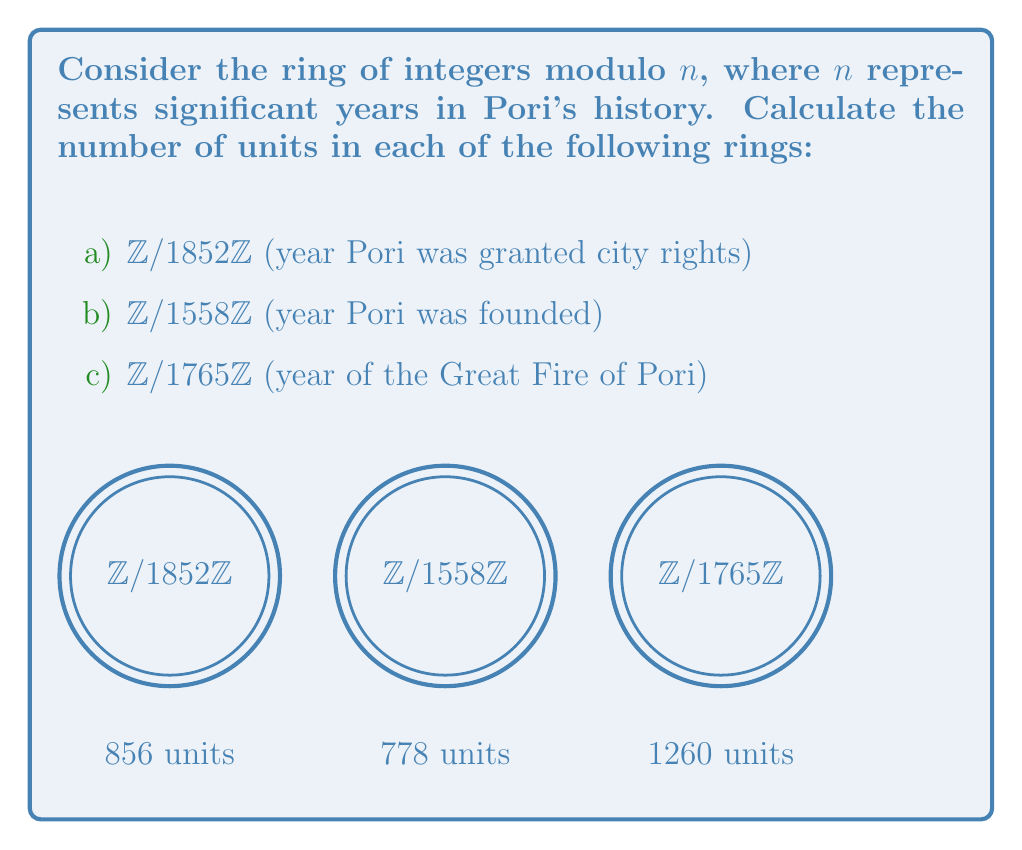Show me your answer to this math problem. To find the number of units in a ring of integers modulo $n$, we need to calculate the Euler totient function $\phi(n)$. The Euler totient function counts the number of integers from 1 to $n$ that are coprime to $n$.

For each case:

a) $n = 1852 = 2^2 \times 463$

To calculate $\phi(1852)$:
$$\phi(1852) = \phi(2^2) \times \phi(463)$$
$$= (2^2 - 2^1) \times (463 - 1)$$
$$= 2 \times 462 = 924$$

b) $n = 1558 = 2 \times 19 \times 41$

To calculate $\phi(1558)$:
$$\phi(1558) = \phi(2) \times \phi(19) \times \phi(41)$$
$$= (2 - 1) \times (19 - 1) \times (41 - 1)$$
$$= 1 \times 18 \times 40 = 720$$

c) $n = 1765 = 5 \times 353$

To calculate $\phi(1765)$:
$$\phi(1765) = \phi(5) \times \phi(353)$$
$$= (5 - 1) \times (353 - 1)$$
$$= 4 \times 352 = 1408$$

Therefore, the number of units in each ring is equal to the corresponding $\phi(n)$ value.
Answer: a) 924, b) 720, c) 1408 